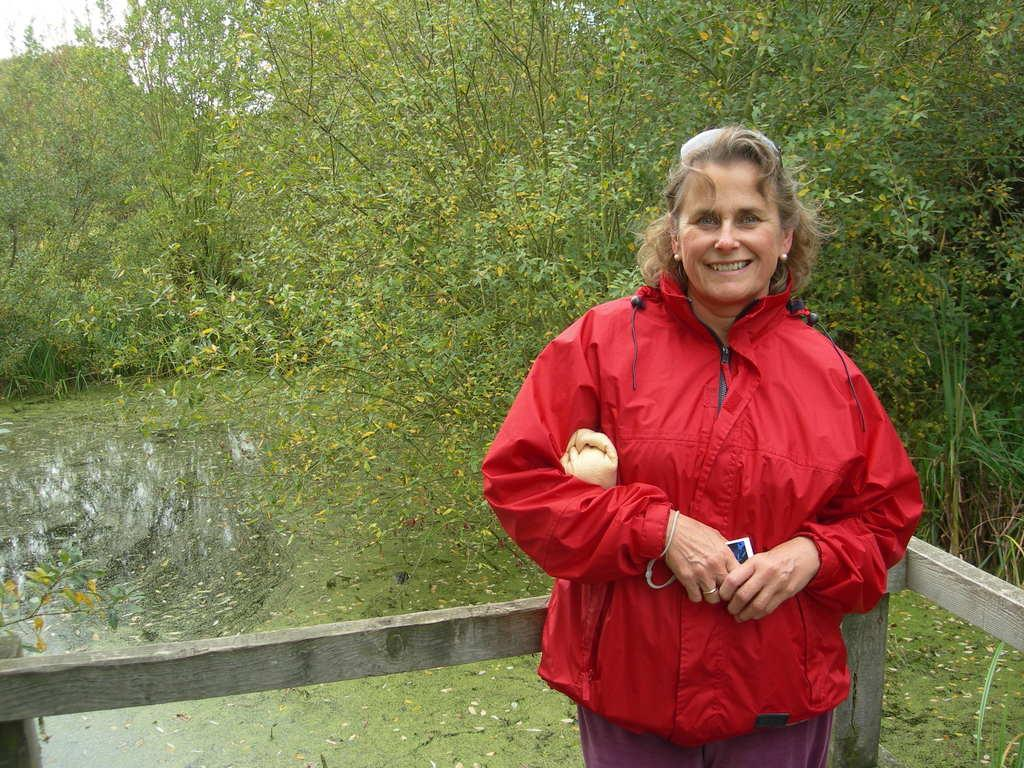Who is present in the image? There is a woman in the image. What is the woman doing in the image? The woman is standing and smiling. What is the woman holding in the image? The woman is holding some objects. What can be seen in the background of the image? There are wooden poles, trees, plants, and water visible in the background of the image. What type of pear is being smashed by the woman's friends in the image? There is no pear or friends present in the image, and therefore no such activity can be observed. 